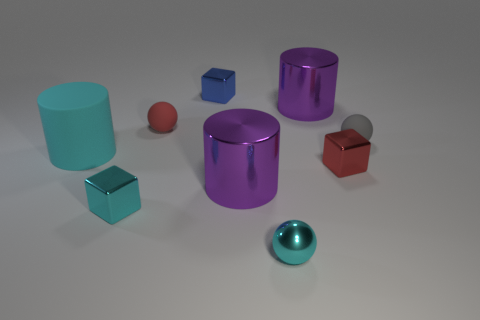Subtract all blocks. How many objects are left? 6 Subtract 0 green cylinders. How many objects are left? 9 Subtract all gray matte balls. Subtract all large metal things. How many objects are left? 6 Add 8 purple cylinders. How many purple cylinders are left? 10 Add 4 large cylinders. How many large cylinders exist? 7 